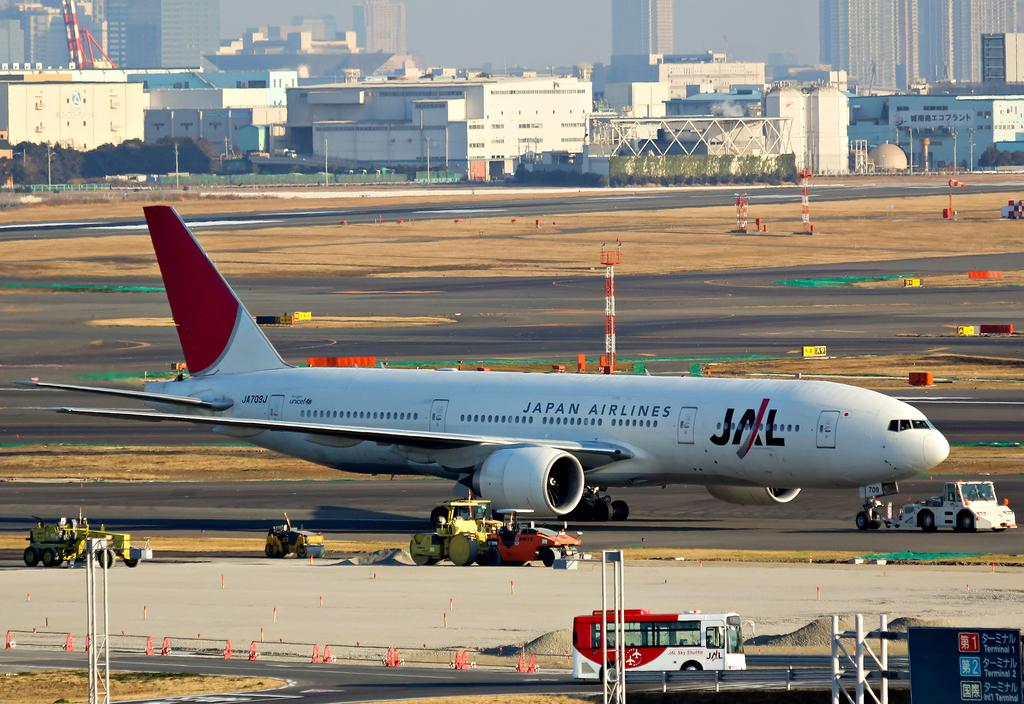<image>
Describe the image concisely. Silver airplane that says "Japan Airlines" parked on the side. 